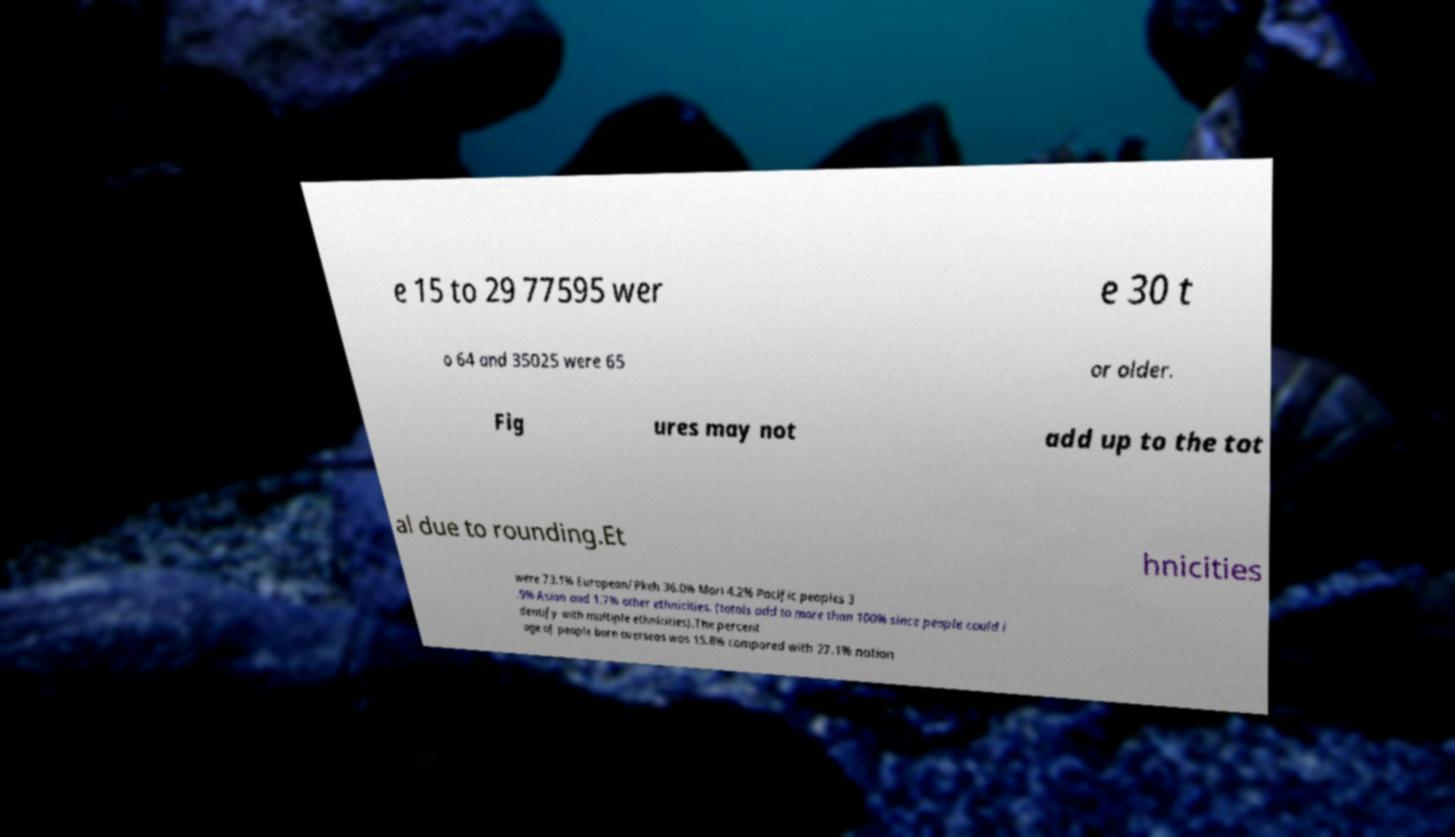Please read and relay the text visible in this image. What does it say? e 15 to 29 77595 wer e 30 t o 64 and 35025 were 65 or older. Fig ures may not add up to the tot al due to rounding.Et hnicities were 73.1% European/Pkeh 36.0% Mori 4.2% Pacific peoples 3 .9% Asian and 1.7% other ethnicities. (totals add to more than 100% since people could i dentify with multiple ethnicities).The percent age of people born overseas was 15.8% compared with 27.1% nation 